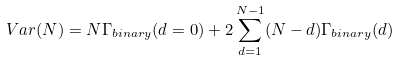<formula> <loc_0><loc_0><loc_500><loc_500>V a r ( N ) = N \Gamma _ { b i n a r y } ( d = 0 ) + 2 \sum _ { d = 1 } ^ { N - 1 } ( N - d ) \Gamma _ { b i n a r y } ( d )</formula> 